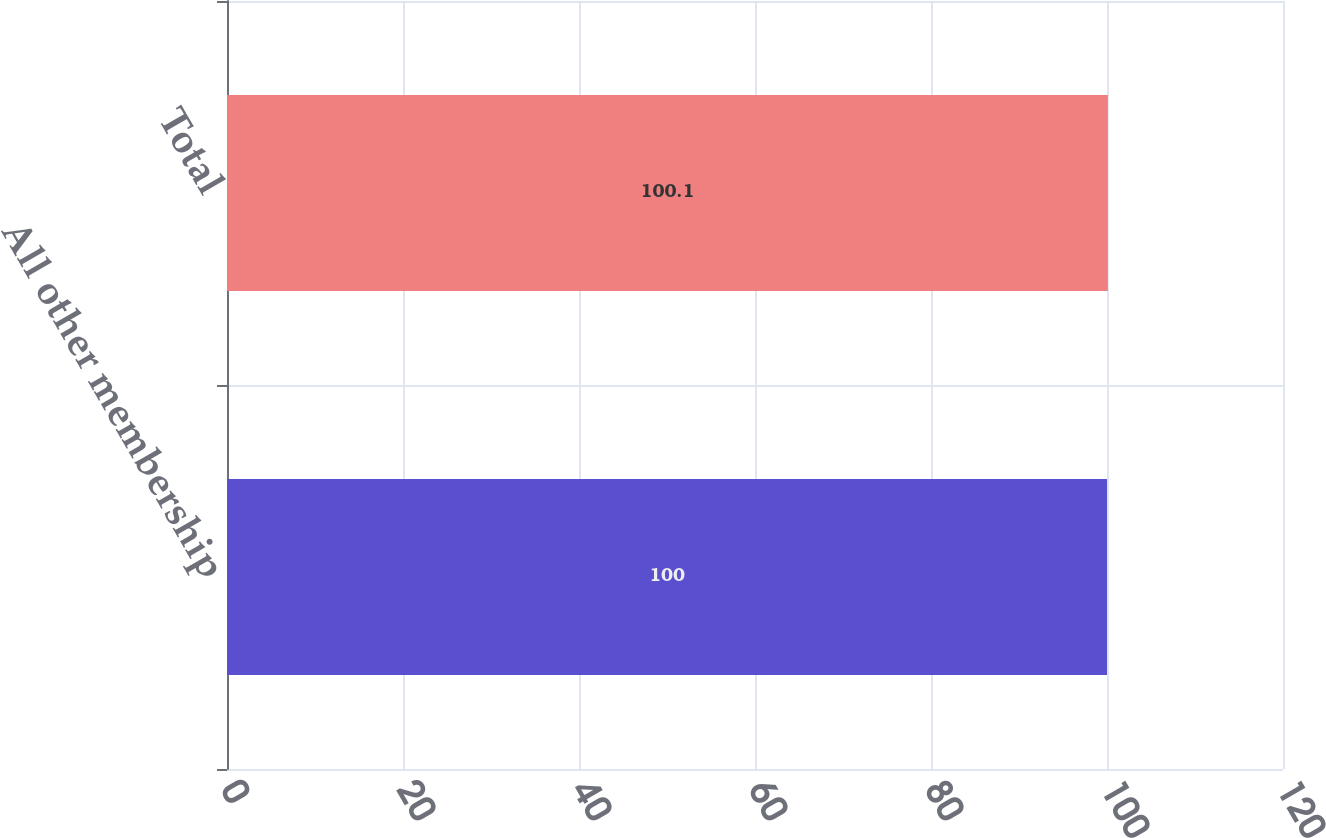Convert chart. <chart><loc_0><loc_0><loc_500><loc_500><bar_chart><fcel>All other membership<fcel>Total<nl><fcel>100<fcel>100.1<nl></chart> 